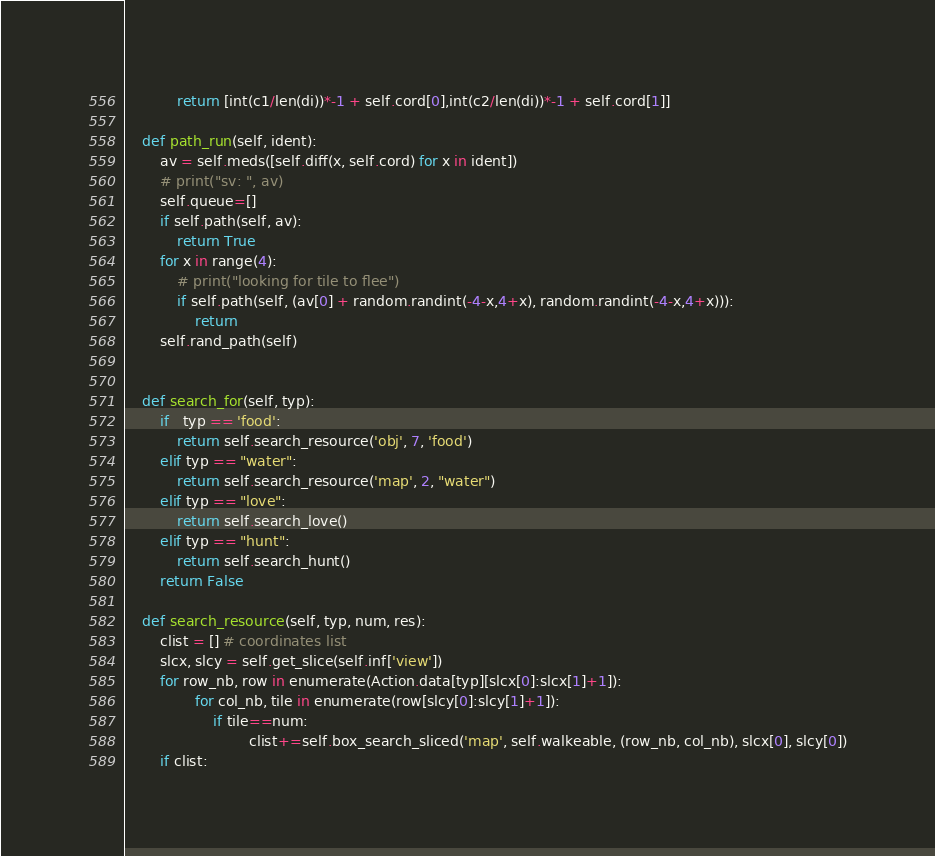Convert code to text. <code><loc_0><loc_0><loc_500><loc_500><_Python_>			return [int(c1/len(di))*-1 + self.cord[0],int(c2/len(di))*-1 + self.cord[1]]

	def path_run(self, ident):			
		av = self.meds([self.diff(x, self.cord) for x in ident])
		# print("sv: ", av)
		self.queue=[]
		if self.path(self, av):
			return True
		for x in range(4): 
			# print("looking for tile to flee")
			if self.path(self, (av[0] + random.randint(-4-x,4+x), random.randint(-4-x,4+x))):
				return
		self.rand_path(self)	


	def search_for(self, typ):
		if   typ == 'food':
			return self.search_resource('obj', 7, 'food')
		elif typ == "water":
			return self.search_resource('map', 2, "water")
		elif typ == "love":
			return self.search_love()
		elif typ == "hunt":
			return self.search_hunt()
		return False

	def search_resource(self, typ, num, res):
		clist = [] # coordinates list
		slcx, slcy = self.get_slice(self.inf['view'])
		for row_nb, row in enumerate(Action.data[typ][slcx[0]:slcx[1]+1]):
				for col_nb, tile in enumerate(row[slcy[0]:slcy[1]+1]):
					if tile==num:
							clist+=self.box_search_sliced('map', self.walkeable, (row_nb, col_nb), slcx[0], slcy[0])
		if clist:</code> 